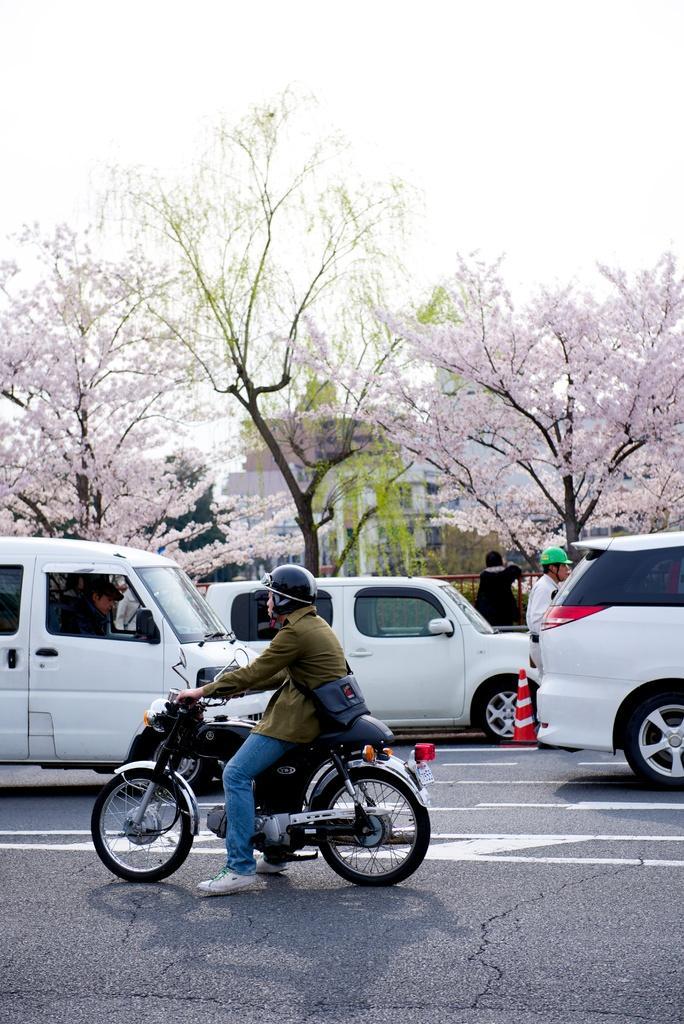Describe this image in one or two sentences. There is a person riding a bicycle on the road. Here we can see three cars on the road. In the background we can see trees and a sky. 